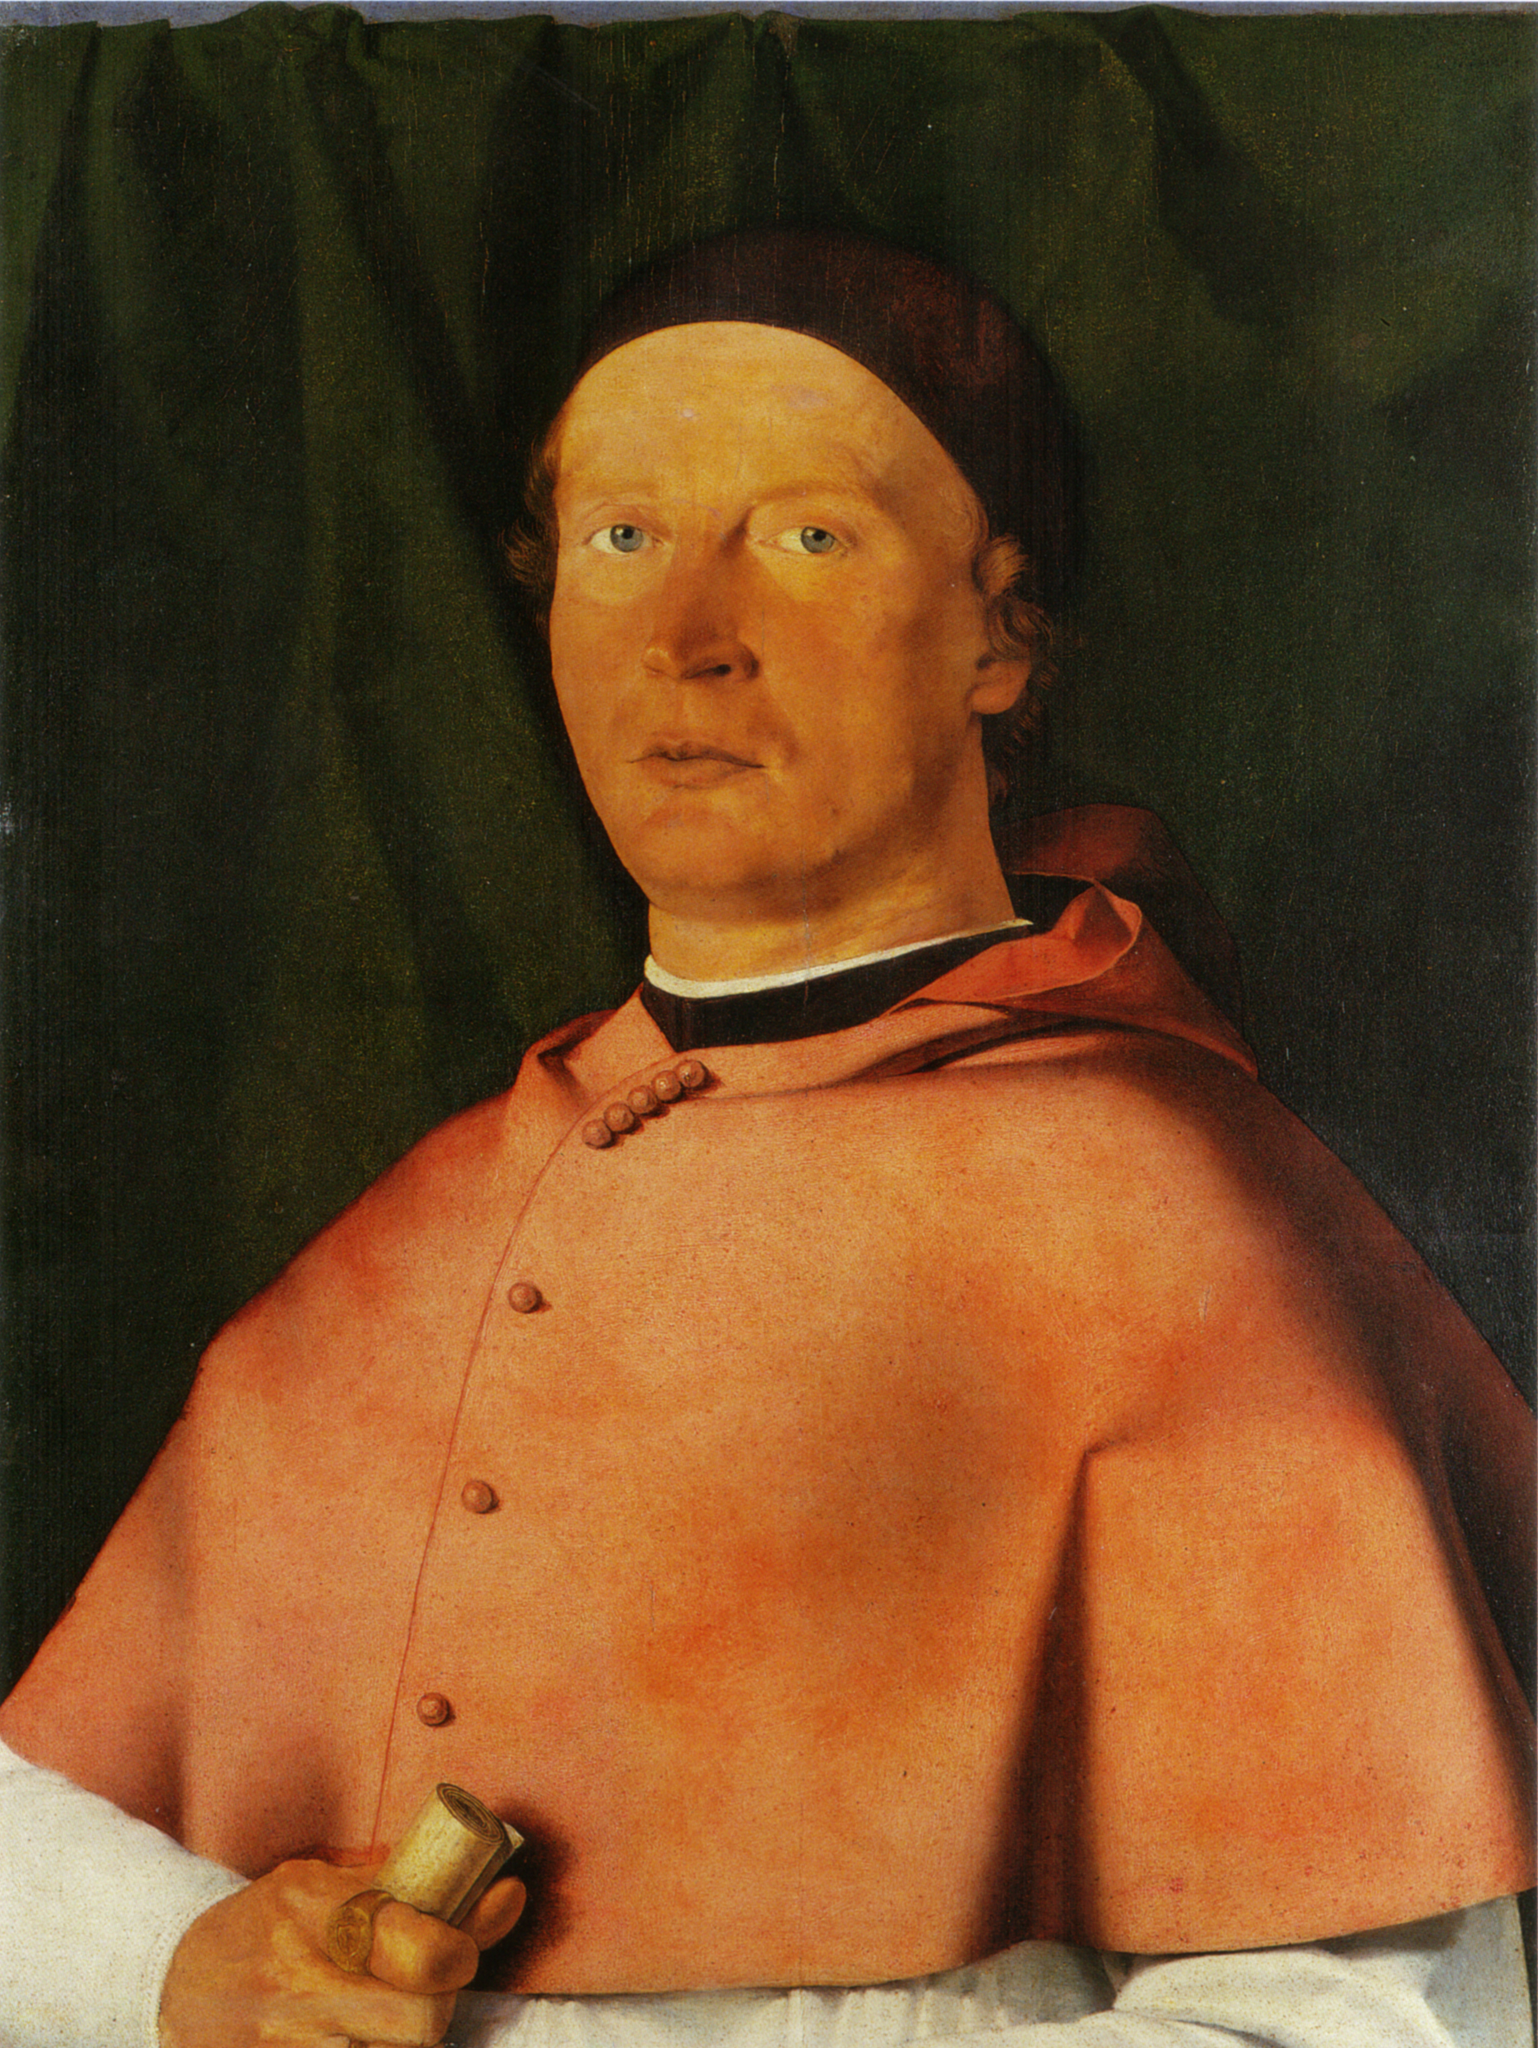Imagine the outfit this man is wearing coming to life. What happens? As the first rays of dawn filter through the chamber’s ornate windows, the vibrant red robe begins to shimmer softly. Threads of gold weave their way through the fabric, illuminating with an ethereal light. The buttons on the robe, now glowing, start to hum musically. The robe slowly detaches itself from the man’s shoulders and begins to dance lightly around the room, seemingly absorbed in a ritual known only to itself. Spectral figures, draped in similar attire, emerge, joining in the majestic dance of honor and tradition, celebrating the knowledge and wisdom it has witnessed. The black cap emits a soft glow, projecting images of ancient scripts and maps onto the walls. As the dance crescendoes, the outfit gently returns to its place, leaving behind an air shimmer of ancient knowledge and deep reverence. 